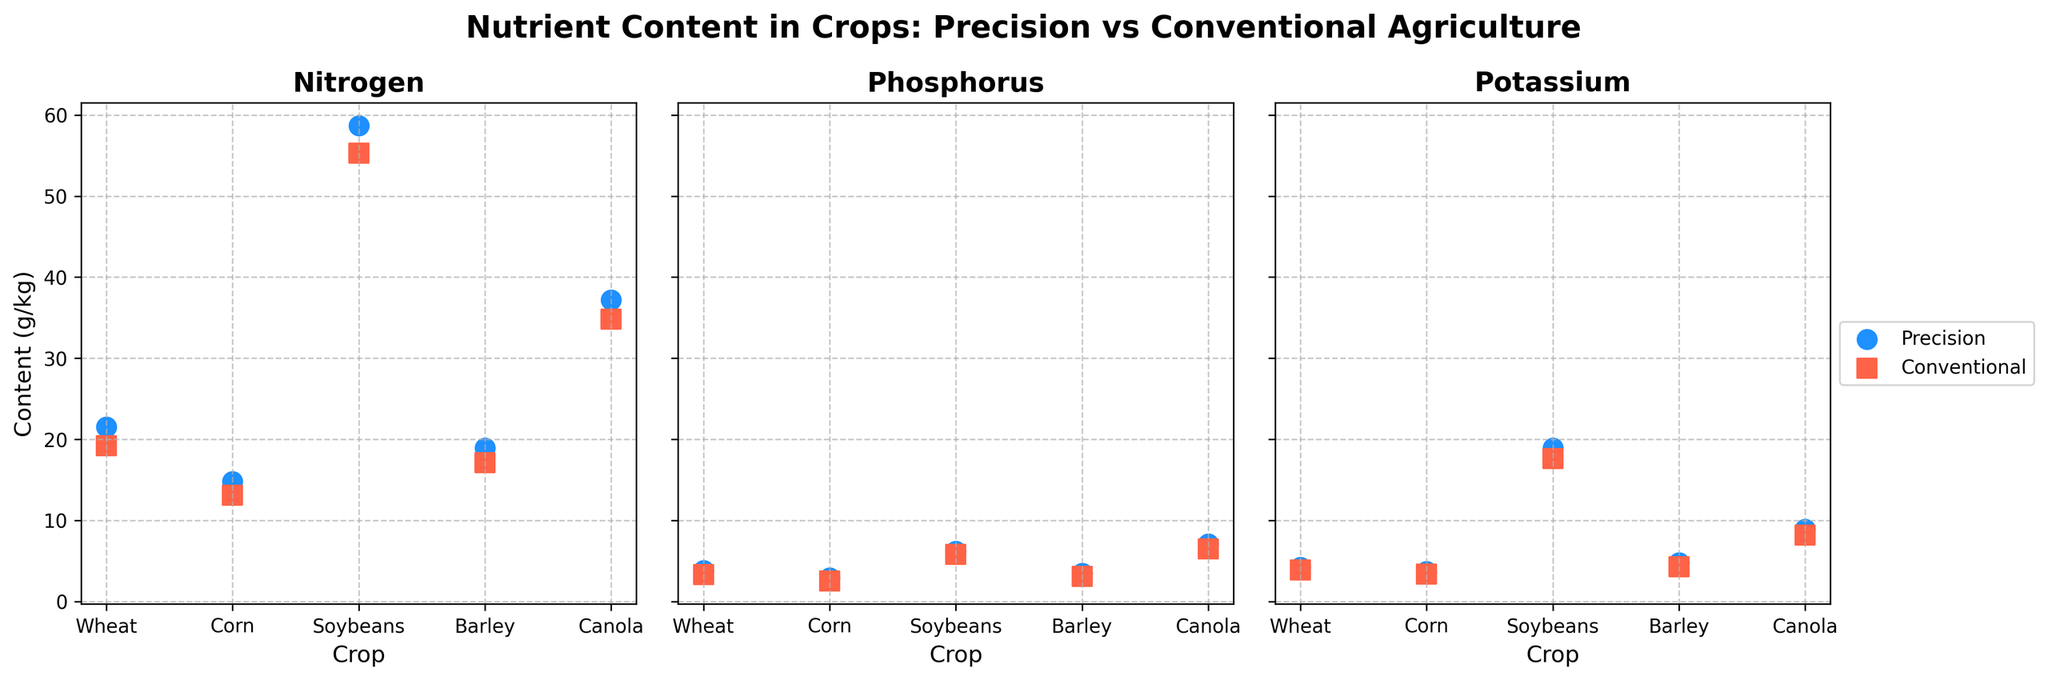What is the title of the figure? The title of the figure is usually found at the top and summarizes what the figure is about. In this case, it reads: "Nutrient Content in Crops: Precision vs Conventional Agriculture".
Answer: Nutrient Content in Crops: Precision vs Conventional Agriculture What are the three nutrients measured in the crops? The nutrients measured are mentioned in the title of each subplot. They are: "Nitrogen (g/kg)", "Phosphorus (g/kg)", and "Potassium (g/kg)".
Answer: Nitrogen, Phosphorus, Potassium Which crop has the highest phosphorus content under precision agriculture? By checking the "Phosphorus" subplot, we can see the highest point for precision agriculture among all crops. In this case, Canola has the highest phosphorus content under precision agriculture.
Answer: Canola How does the nitrogen content in wheat compare between the precision and conventional methods? Look at the nitrogen subplot and compare the nitrogen content for wheat (indicated by dots for precision and squares for conventional). Wheat has 21.5 g/kg nitrogen in precision and 19.2 g/kg nitrogen in conventional methods.
Answer: Higher in precision Which method has a higher potassium content for soybeans? Look at the potassium subplot and compare the values for soybeans. Precision agriculture shows a higher potassium content (18.9 g/kg) compared to conventional methods (17.6 g/kg).
Answer: Precision Which nutrient shows the smallest difference between precision and conventional methods across all crops? To determine this, we need to compare the differences for nitrogen, phosphorus, and potassium in each crop for both methods. Nitrogen appears to show the smallest difference, as the shifts between precision and conventional are relatively smaller than the other nutrients.
Answer: Nitrogen How does phosphorus content in barley grown with precision agriculture compare to that grown with conventional methods? Check the phosphorus subplot. For barley, precision agriculture shows a phosphorus content of 3.5 g/kg, while the conventional method shows 3.1 g/kg.
Answer: Higher in precision Which crop has the most significant difference in nitrogen content between precision and conventional methods? Calculate the differences in nitrogen content between precision and conventional methods for each crop. Soybeans have the largest difference, with a difference of 58.7 - 55.3 = 3.4 g/kg.
Answer: Soybeans What is the average potassium content in all crops grown with conventional methods? To find this, sum the potassium content for all crops under conventional methods and divide by the number of crops: (3.9 + 3.4 + 17.6 + 4.3 + 8.2) / 5 = 37.4 / 5 = 7.48 g/kg.
Answer: 7.48 g/kg Which method generally resulted in higher nutrient contents? By observing the plots, precision agriculture shows generally higher nutrient contents in most cases compared to conventional methods.
Answer: Precision 